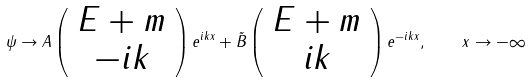<formula> <loc_0><loc_0><loc_500><loc_500>\psi \to A \left ( \begin{array} { c } { E + m } \\ { - i k } \end{array} \right ) e ^ { i k x } + \tilde { B } \left ( \begin{array} { c } { E + m } \\ { i k } \end{array} \right ) e ^ { - i k x } , \quad x \to - \infty</formula> 